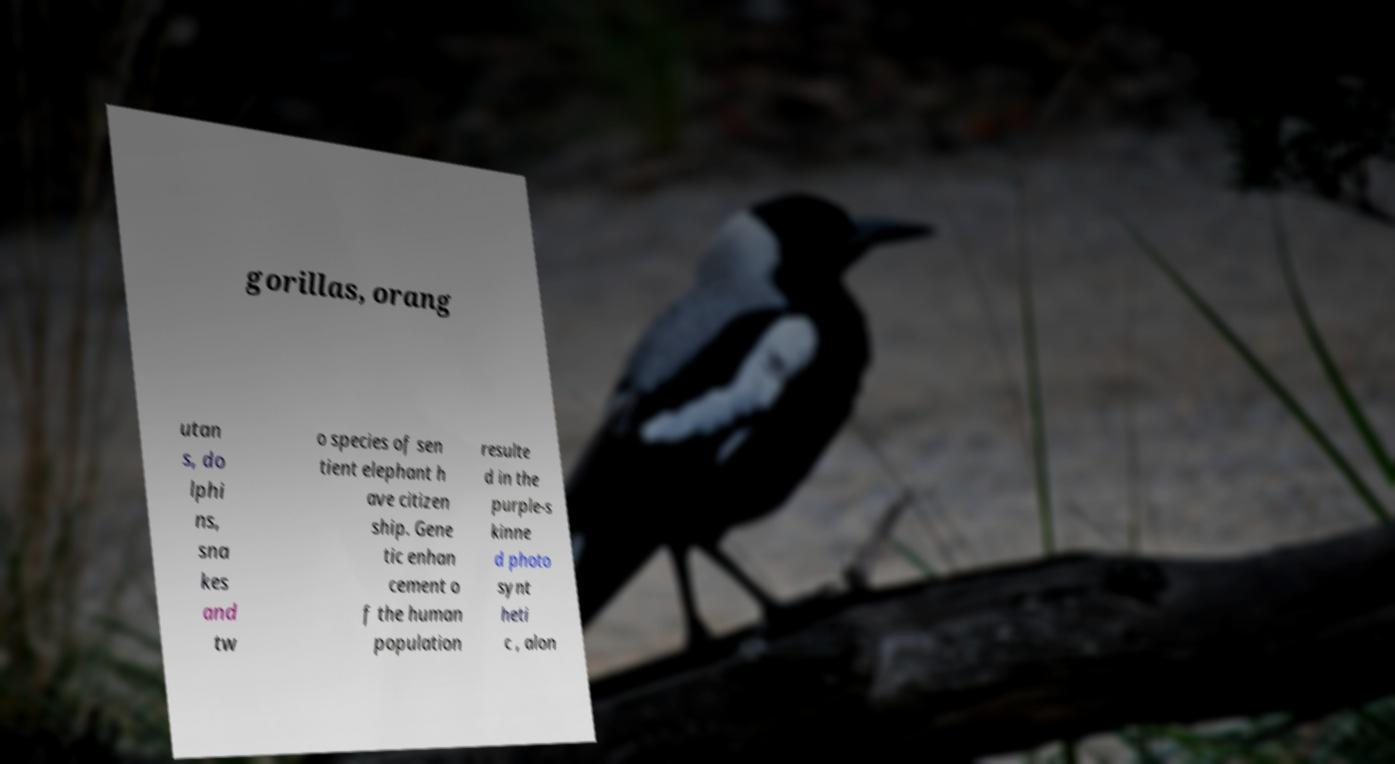I need the written content from this picture converted into text. Can you do that? gorillas, orang utan s, do lphi ns, sna kes and tw o species of sen tient elephant h ave citizen ship. Gene tic enhan cement o f the human population resulte d in the purple-s kinne d photo synt heti c , alon 